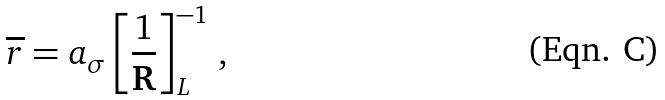<formula> <loc_0><loc_0><loc_500><loc_500>\overline { r } = a _ { \sigma } \left [ \frac { 1 } { \mathbf R } \right ] _ { L } ^ { - 1 } \, ,</formula> 